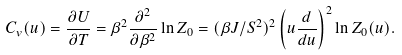Convert formula to latex. <formula><loc_0><loc_0><loc_500><loc_500>C _ { v } ( u ) = \frac { \partial U } { \partial T } = \beta ^ { 2 } \frac { \partial ^ { 2 } } { \partial \beta ^ { 2 } } \ln Z _ { 0 } = ( \beta J / S ^ { 2 } ) ^ { 2 } \left ( u \frac { d } { d u } \right ) ^ { 2 } \ln Z _ { 0 } ( u ) .</formula> 